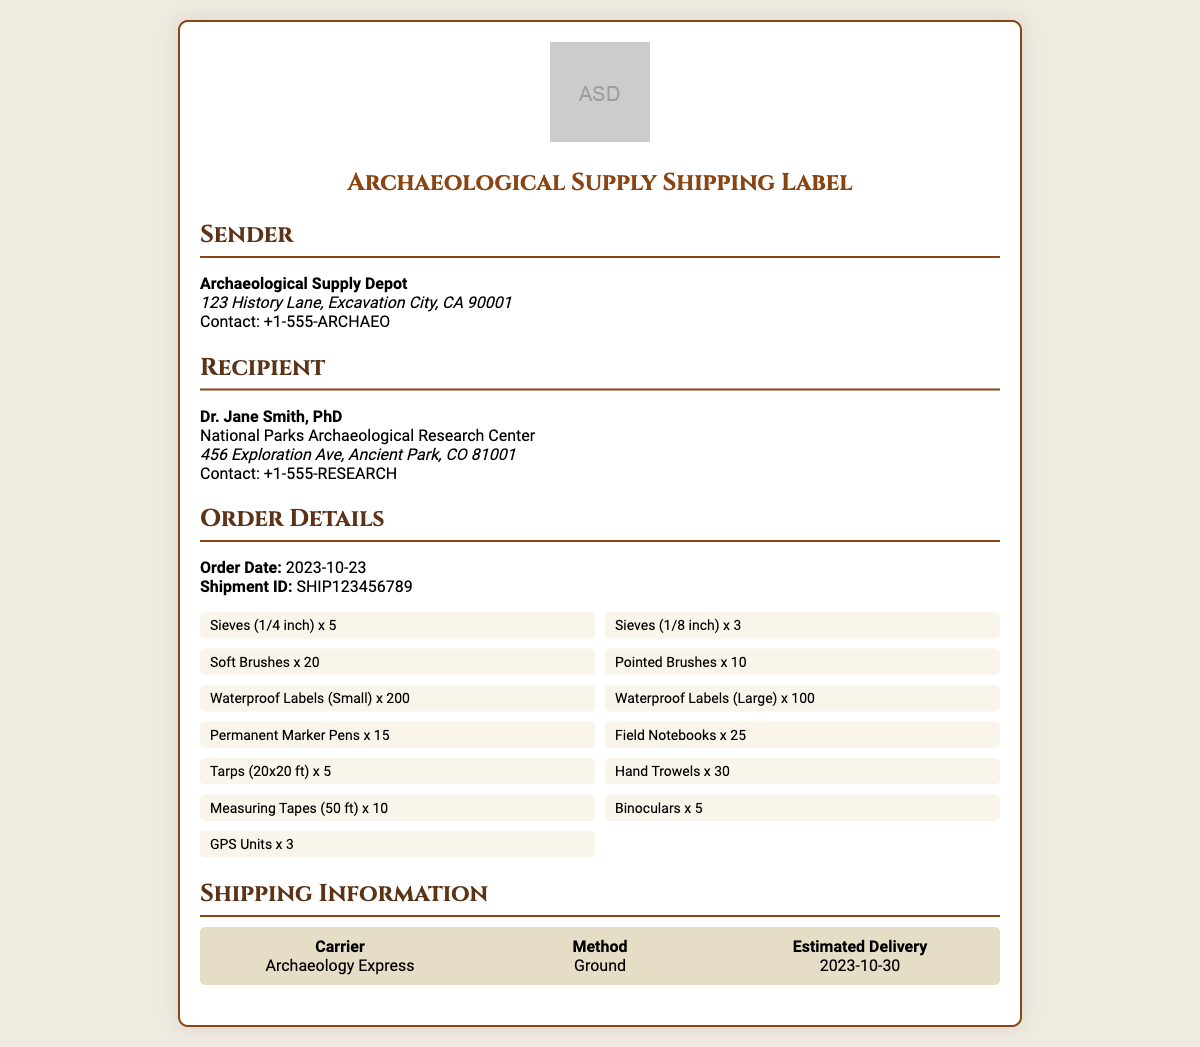What is the sender's name? The sender's name is prominently displayed in the document as the Archaeological Supply Depot.
Answer: Archaeological Supply Depot What is the recipient's contact number? The recipient's contact number is listed in the document under the recipient section.
Answer: +1-555-RESEARCH How many Soft Brushes are included in the shipment? The number of Soft Brushes is specified in the item list of the order details.
Answer: 20 What is the estimated delivery date? The estimated delivery date is stated in the shipping information section of the document.
Answer: 2023-10-30 What is the shipment ID? The shipment ID is presented clearly in the order details section.
Answer: SHIP123456789 How many types of sieves are there? The document lists two types of sieves in the item section, specified by their sizes.
Answer: 2 What shipping method is used? The method of shipping is provided in the shipping information section.
Answer: Ground Who is the recipient? The recipient's name is given in the recipient section of the document.
Answer: Dr. Jane Smith, PhD What is the quantity of Permanent Marker Pens? The quantity for Permanent Marker Pens can be found in the items list.
Answer: 15 